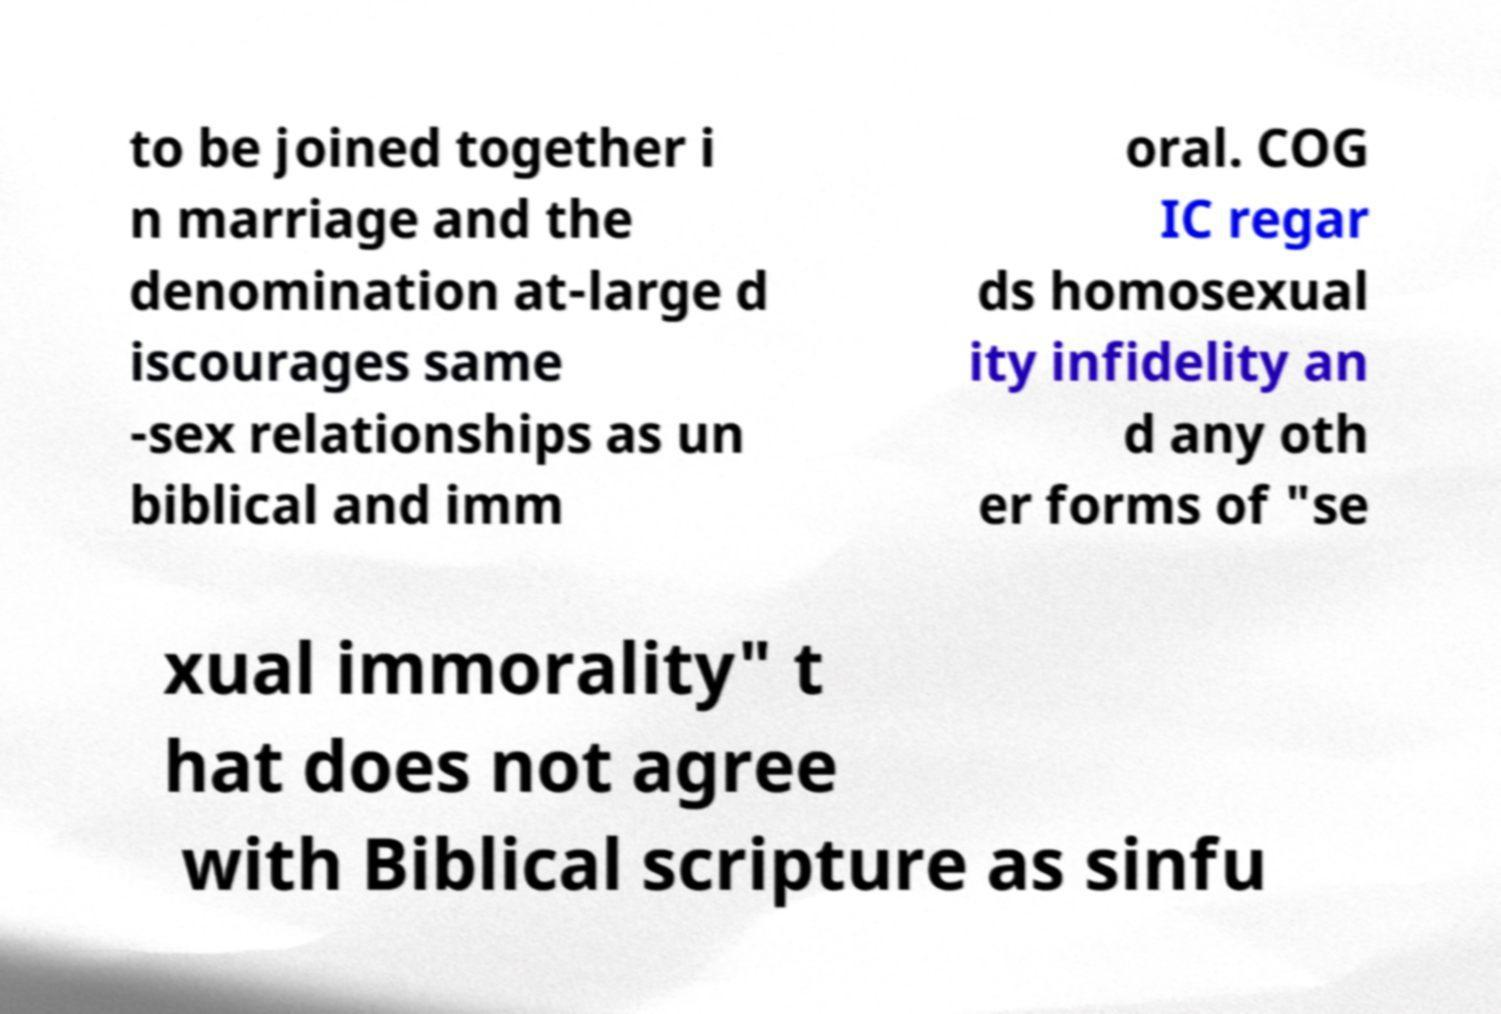For documentation purposes, I need the text within this image transcribed. Could you provide that? to be joined together i n marriage and the denomination at-large d iscourages same -sex relationships as un biblical and imm oral. COG IC regar ds homosexual ity infidelity an d any oth er forms of "se xual immorality" t hat does not agree with Biblical scripture as sinfu 